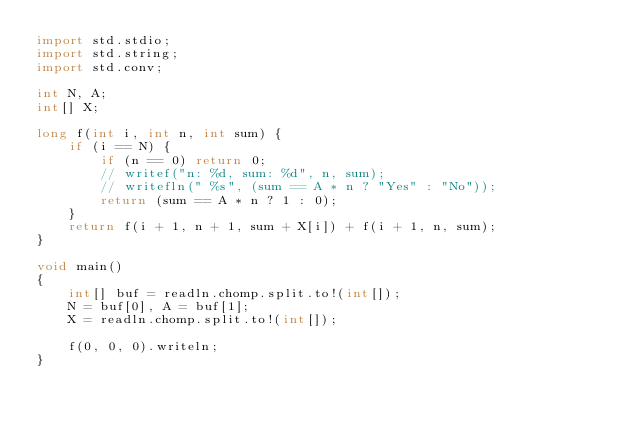Convert code to text. <code><loc_0><loc_0><loc_500><loc_500><_D_>import std.stdio;
import std.string;
import std.conv;

int N, A;
int[] X;

long f(int i, int n, int sum) {
    if (i == N) { 
        if (n == 0) return 0;
        // writef("n: %d, sum: %d", n, sum);
        // writefln(" %s", (sum == A * n ? "Yes" : "No"));
        return (sum == A * n ? 1 : 0);
    }
    return f(i + 1, n + 1, sum + X[i]) + f(i + 1, n, sum);
}

void main()
{
    int[] buf = readln.chomp.split.to!(int[]);
    N = buf[0], A = buf[1];
    X = readln.chomp.split.to!(int[]);

    f(0, 0, 0).writeln;
}
</code> 